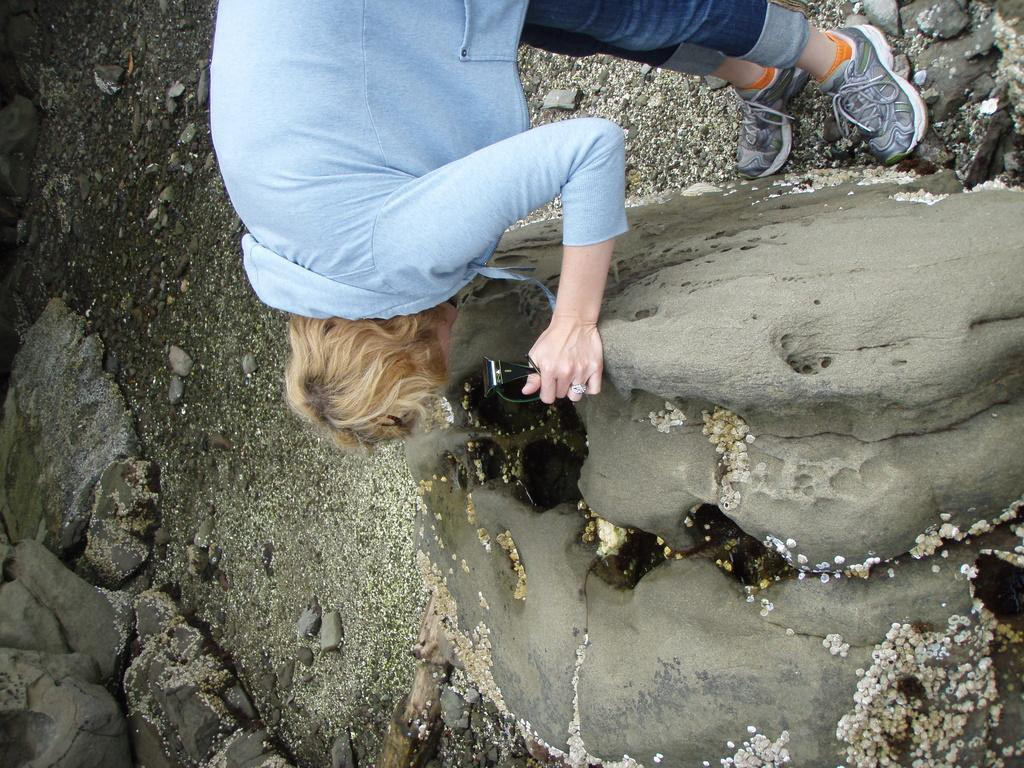What is the main subject of the image? There is a person in the image. What is the person doing in the image? The person is bending. What is the person holding in the image? The person is holding an object. What can be seen at the bottom of the image? There are rocks at the bottom of the image. What type of lettuce can be seen growing near the rocks in the image? There is no lettuce present in the image; it only features a person bending and holding an object, with rocks at the bottom. 